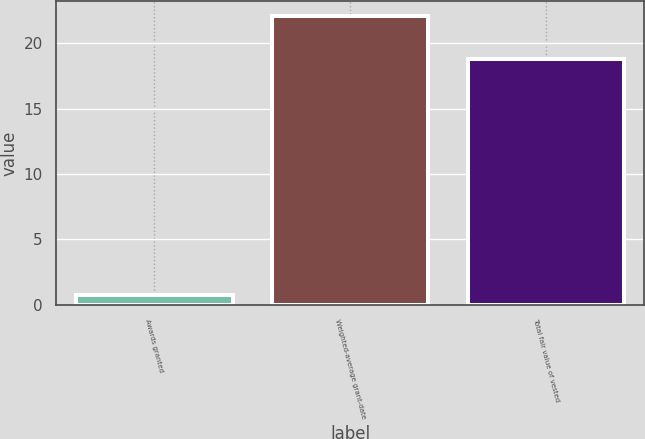<chart> <loc_0><loc_0><loc_500><loc_500><bar_chart><fcel>Awards granted<fcel>Weighted-average grant-date<fcel>Total fair value of vested<nl><fcel>0.8<fcel>22.07<fcel>18.8<nl></chart> 